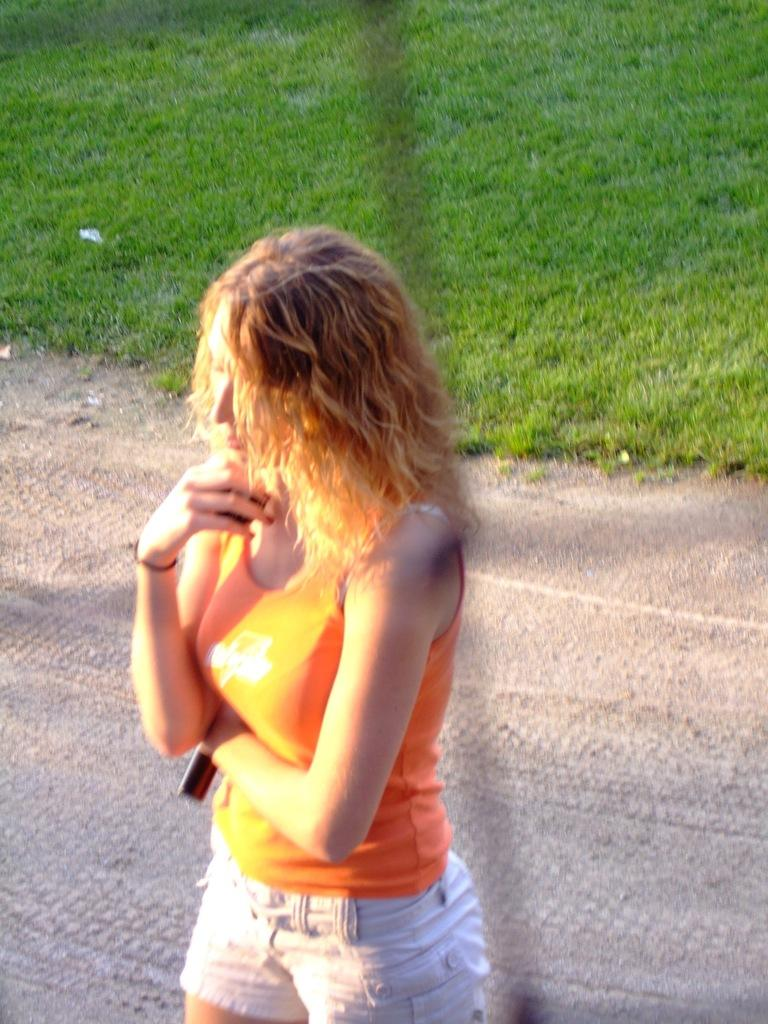Who is present in the image? There is a woman in the image. What is the woman doing in the image? The woman is holding an object and standing. What can be seen in the background of the image? There is grass in the background of the image. What type of alley can be seen in the background of the image? There is no alley present in the image; it features a woman standing with grass in the background. How is the woman involved in the distribution process in the image? There is no distribution process depicted in the image, and the woman is simply standing with an object in her hand. 